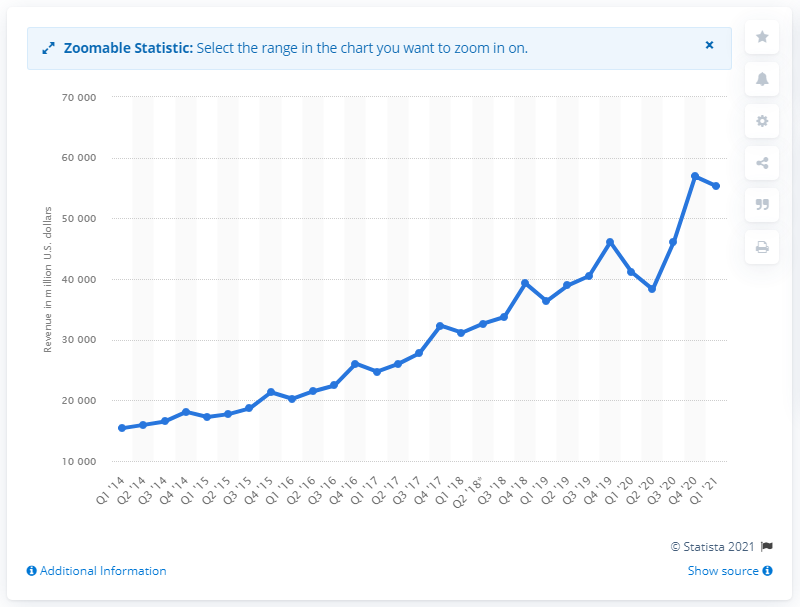Point out several critical features in this image. Alphabet's revenue in the first quarter of 2021 was $55,314. Alphabet, the parent company of Google, reported a revenue of $41,159 million in the first quarter of 2021. 